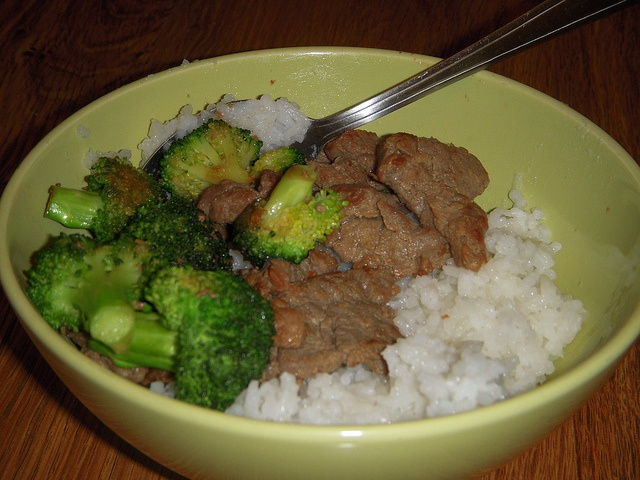Describe the objects in this image and their specific colors. I can see bowl in black, olive, and darkgray tones, dining table in black, maroon, and olive tones, broccoli in black, darkgreen, and olive tones, fork in black, gray, and darkgreen tones, and broccoli in black, darkgreen, and maroon tones in this image. 